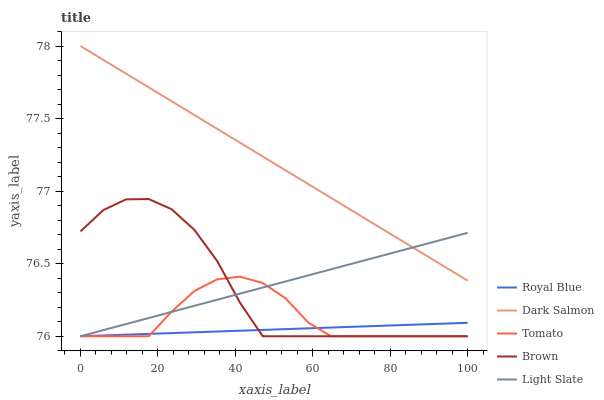Does Royal Blue have the minimum area under the curve?
Answer yes or no. Yes. Does Dark Salmon have the maximum area under the curve?
Answer yes or no. Yes. Does Dark Salmon have the minimum area under the curve?
Answer yes or no. No. Does Royal Blue have the maximum area under the curve?
Answer yes or no. No. Is Dark Salmon the smoothest?
Answer yes or no. Yes. Is Brown the roughest?
Answer yes or no. Yes. Is Royal Blue the smoothest?
Answer yes or no. No. Is Royal Blue the roughest?
Answer yes or no. No. Does Tomato have the lowest value?
Answer yes or no. Yes. Does Dark Salmon have the lowest value?
Answer yes or no. No. Does Dark Salmon have the highest value?
Answer yes or no. Yes. Does Royal Blue have the highest value?
Answer yes or no. No. Is Brown less than Dark Salmon?
Answer yes or no. Yes. Is Dark Salmon greater than Royal Blue?
Answer yes or no. Yes. Does Light Slate intersect Dark Salmon?
Answer yes or no. Yes. Is Light Slate less than Dark Salmon?
Answer yes or no. No. Is Light Slate greater than Dark Salmon?
Answer yes or no. No. Does Brown intersect Dark Salmon?
Answer yes or no. No. 